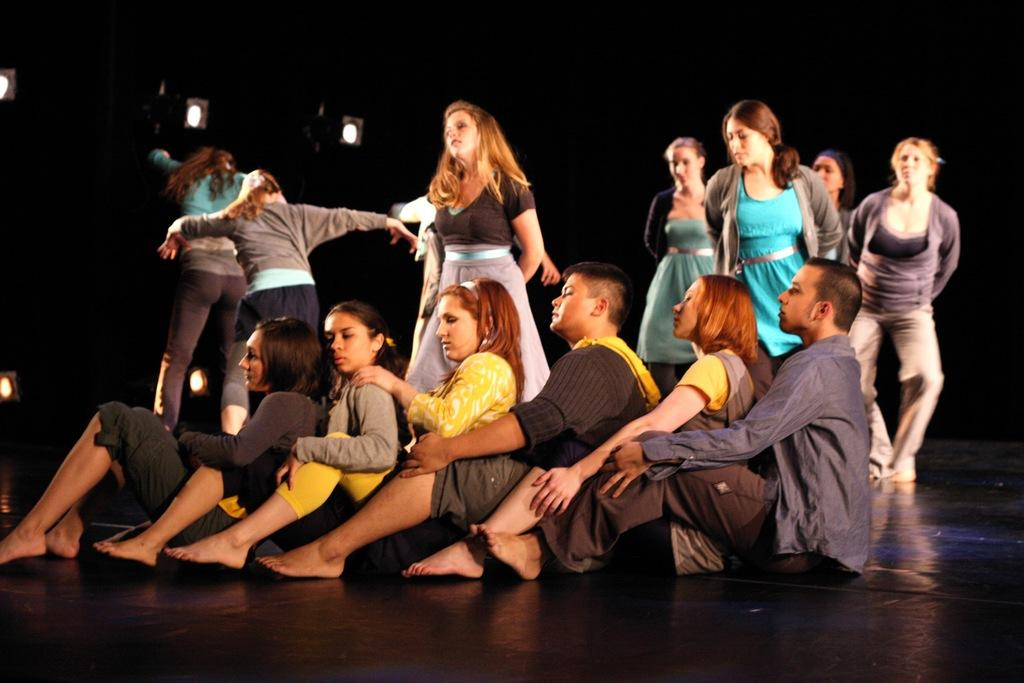How many people are in the image? There are many people in the image. What are some of the positions the people are in? Some people are sitting on the floor, while others are standing. What can be seen in the image that provides illumination? There are lights present in the image. What is the purpose of the girls in the image? There is no mention of girls in the image, so we cannot determine their purpose. 